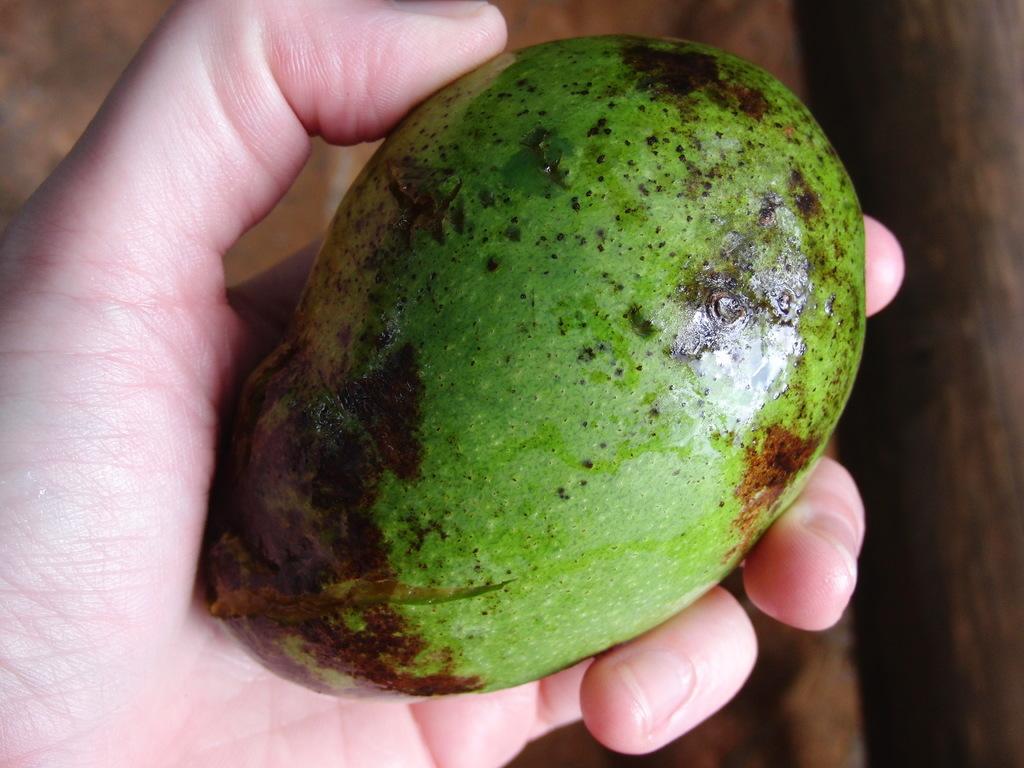How would you summarize this image in a sentence or two? In this picture we can see a raw mango and a person this raw mango in his hand. 